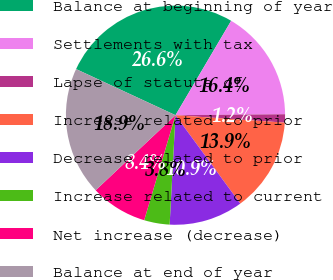Convert chart. <chart><loc_0><loc_0><loc_500><loc_500><pie_chart><fcel>Balance at beginning of year<fcel>Settlements with tax<fcel>Lapse of statute of<fcel>Increase related to prior<fcel>Decrease related to prior<fcel>Increase related to current<fcel>Net increase (decrease)<fcel>Balance at end of year<nl><fcel>26.57%<fcel>16.38%<fcel>1.22%<fcel>13.85%<fcel>10.92%<fcel>3.76%<fcel>8.38%<fcel>18.92%<nl></chart> 